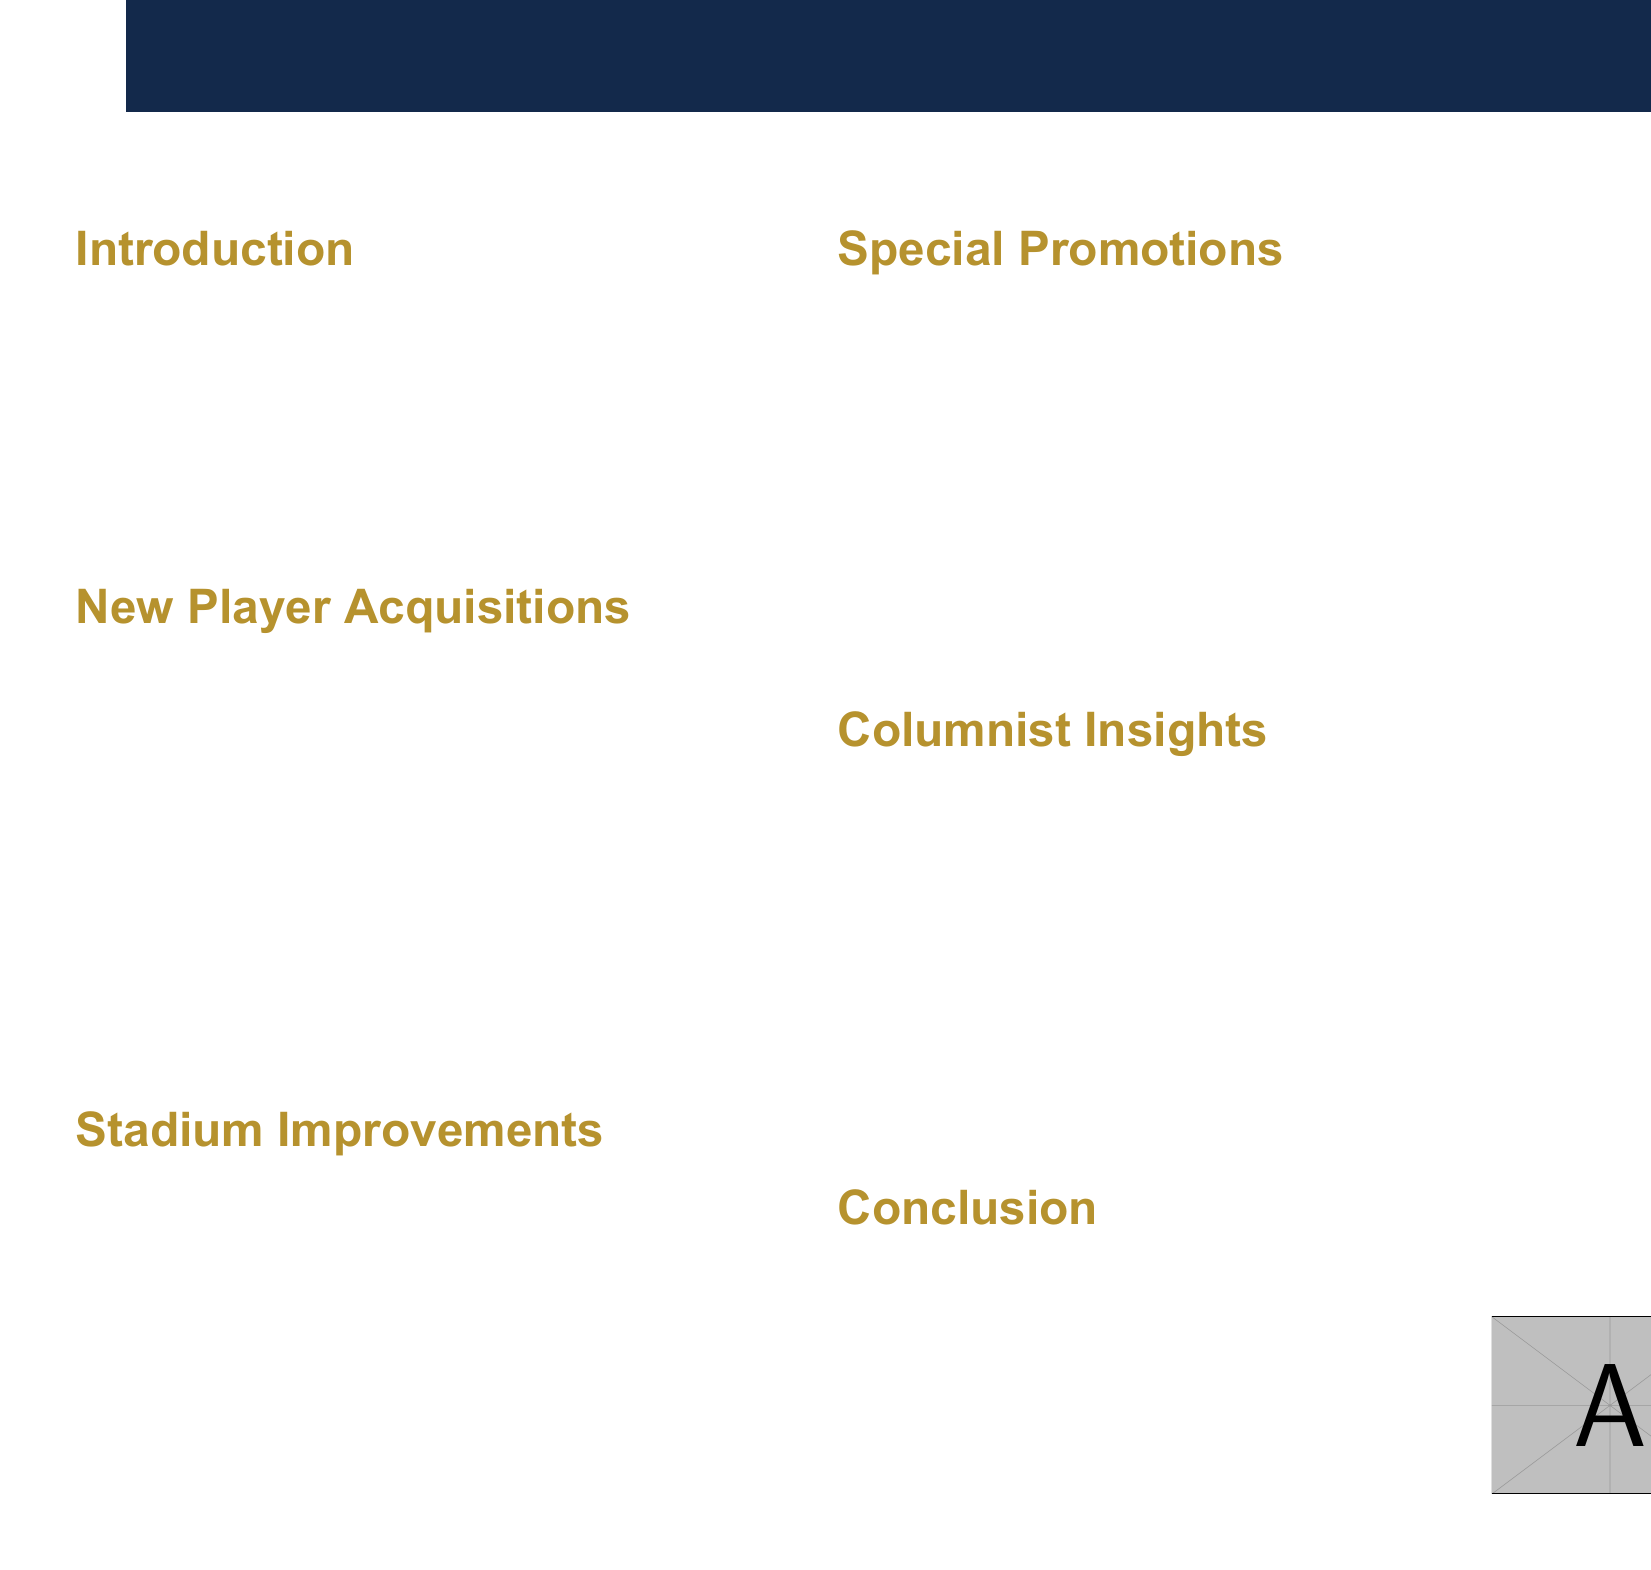What is the title of the brochure? The title of the brochure is explicitly stated at the top of the document.
Answer: Brew Crew 2023: A Season of Excitement Who is a new player acquisition for the Brewers? The document lists several new players acquired by the Brewers.
Answer: Jesse Winker What position does William Contreras play? The document provides the positions for the new player acquisitions.
Answer: Catcher When is Yelich Bobblehead Day? The date of this special promotion is mentioned in the promotions section of the brochure.
Answer: June 18, 2023 What is one of the stadium improvements? The document lists improvements made to the stadium, highlighting their features.
Answer: Enhanced LED Lighting What analysis is provided regarding new player acquisitions? The insights section discusses the impact of new players on the team's performance.
Answer: The additions of Winker and Contreras significantly bolster the Brewers' offensive capabilities How many home games feature Retro Sundays? The frequency of this promotion is detailed in the promotions section of the document.
Answer: Every Sunday home game What is the benefit of the expanded local craft beer selection? Each stadium improvement includes a benefit for the fans.
Answer: Celebrates Milwaukee's brewing heritage and supports local businesses 